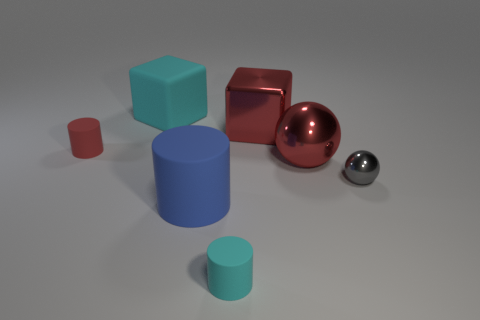There is a cube that is left of the cyan cylinder that is to the right of the blue cylinder; what is its color?
Offer a very short reply. Cyan. There is a matte cylinder that is the same size as the red metal cube; what color is it?
Ensure brevity in your answer.  Blue. How many large metallic objects are both on the left side of the big red sphere and in front of the red metallic block?
Make the answer very short. 0. There is a rubber object that is the same color as the matte block; what is its shape?
Give a very brief answer. Cylinder. What is the object that is behind the tiny ball and in front of the red cylinder made of?
Your answer should be very brief. Metal. Are there fewer rubber objects right of the cyan rubber cylinder than small objects in front of the red rubber cylinder?
Keep it short and to the point. Yes. The cyan cylinder that is the same material as the small red cylinder is what size?
Offer a terse response. Small. Are there any other things that are the same color as the big rubber cylinder?
Keep it short and to the point. No. Do the blue cylinder and the cyan cylinder to the left of the small metal ball have the same material?
Provide a succinct answer. Yes. There is a large object that is the same shape as the small red object; what is its material?
Your answer should be very brief. Rubber. 